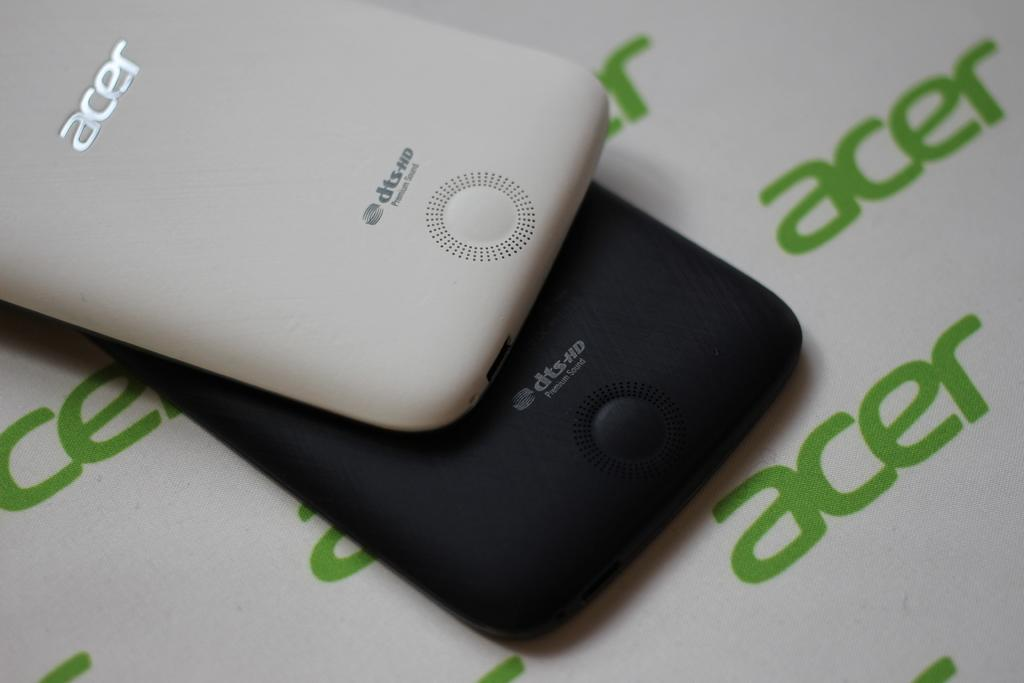How many objects are present in the image? There are two objects in the image. What colors are the objects? The objects are in white and black colors. What word is written on the objects? The word "acer" is written on the objects. Can you see any snails crawling on the objects in the image? There are no snails present in the image. Is there any sleet visible in the image? There is no sleet present in the image. 